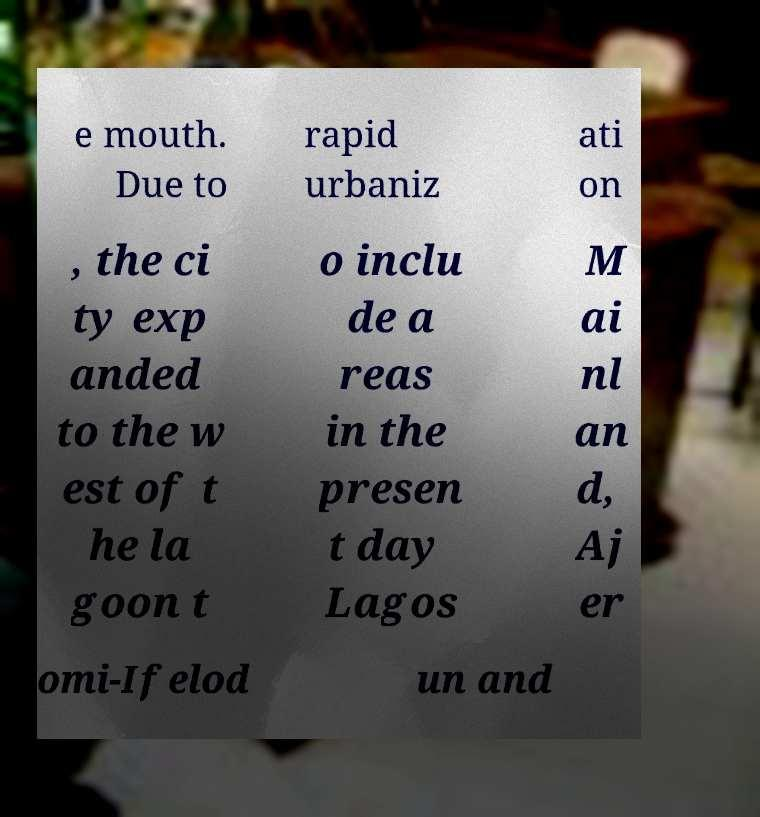For documentation purposes, I need the text within this image transcribed. Could you provide that? e mouth. Due to rapid urbaniz ati on , the ci ty exp anded to the w est of t he la goon t o inclu de a reas in the presen t day Lagos M ai nl an d, Aj er omi-Ifelod un and 